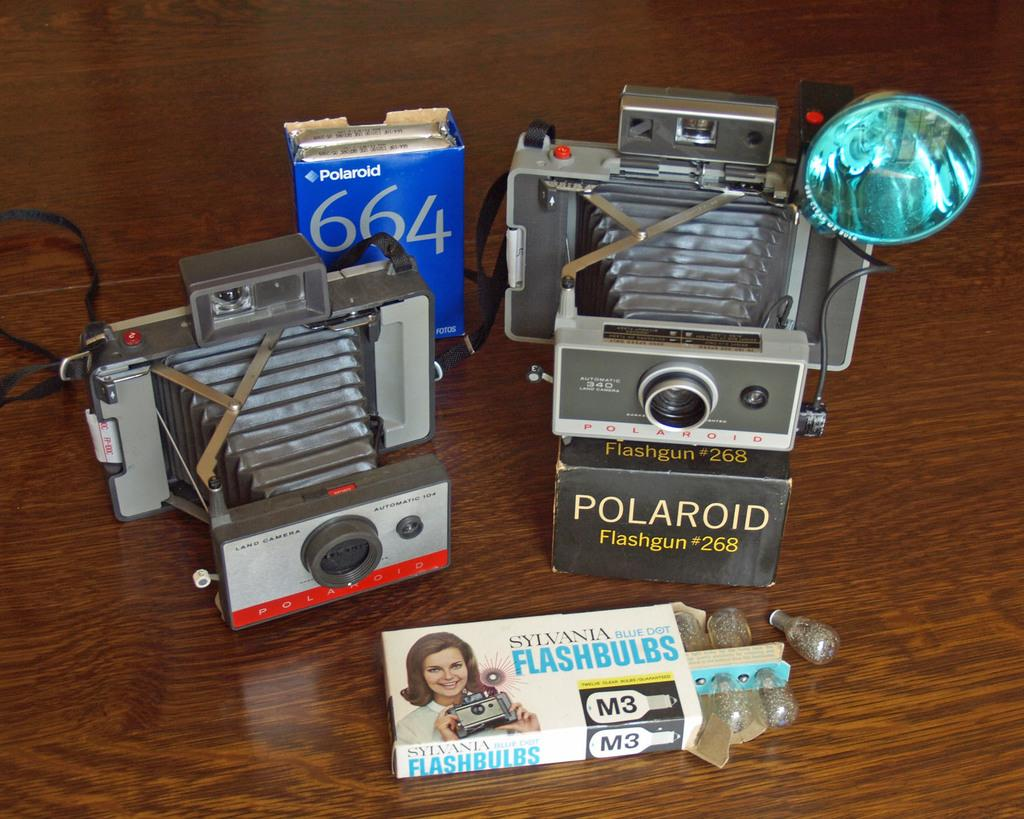How many devices can be seen in the image? There are two devices in the image. What else is present in the image besides the devices? There are three boxes in the image. Where are the boxes located? The boxes are placed on a table. What can be found on the boxes? There is text and an image of a woman on the boxes. How many ladybugs are crawling on the devices in the image? There are no ladybugs present in the image. What expertise do the people in the image have? There is no indication of any people or their expertise in the image. 